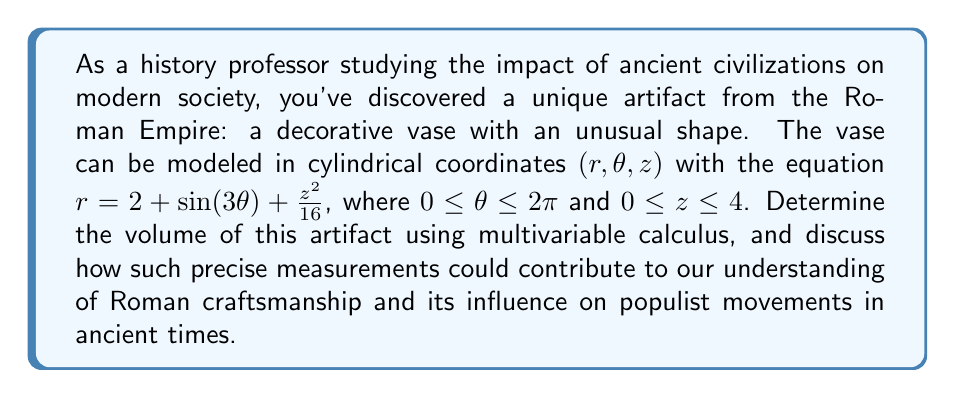What is the answer to this math problem? To find the volume of this complex historical artifact, we need to set up and evaluate a triple integral in cylindrical coordinates. The steps are as follows:

1) The volume integral in cylindrical coordinates is given by:

   $$V = \iiint_V r \, dr \, d\theta \, dz$$

2) We need to determine the limits of integration:
   - $0 \leq \theta \leq 2\pi$
   - $0 \leq z \leq 4$
   - $0 \leq r \leq 2 + \sin(3\theta) + \frac{z^2}{16}$

3) Set up the triple integral:

   $$V = \int_0^4 \int_0^{2\pi} \int_0^{2 + \sin(3\theta) + \frac{z^2}{16}} r \, dr \, d\theta \, dz$$

4) Evaluate the innermost integral with respect to $r$:

   $$V = \int_0^4 \int_0^{2\pi} \left[\frac{r^2}{2}\right]_0^{2 + \sin(3\theta) + \frac{z^2}{16}} \, d\theta \, dz$$
   
   $$V = \int_0^4 \int_0^{2\pi} \frac{1}{2}\left(2 + \sin(3\theta) + \frac{z^2}{16}\right)^2 \, d\theta \, dz$$

5) Expand the squared term:

   $$V = \int_0^4 \int_0^{2\pi} \frac{1}{2}\left(4 + 4\sin(3\theta) + \frac{z^2}{4} + \sin^2(3\theta) + \frac{z^2}{8}\sin(3\theta) + \frac{z^4}{256}\right) \, d\theta \, dz$$

6) Integrate with respect to $\theta$:

   $$V = \int_0^4 \left[\frac{1}{2}\left(4\theta + \frac{4}{3}\cos(3\theta) + \frac{z^2}{4}\theta + \frac{1}{2}\theta - \frac{1}{12}\cos(6\theta) + \frac{z^2}{24}\cos(3\theta) + \frac{z^4}{256}\theta\right)\right]_0^{2\pi} \, dz$$

7) Evaluate the limits for $\theta$:

   $$V = \int_0^4 \left(4\pi + \frac{\pi z^2}{2} + \pi + \frac{\pi z^4}{256}\right) \, dz$$

8) Integrate with respect to $z$:

   $$V = \left[4\pi z + \frac{\pi z^3}{6} + \pi z + \frac{\pi z^5}{1280}\right]_0^4$$

9) Evaluate the limits for $z$:

   $$V = 16\pi + \frac{64\pi}{6} + 4\pi + \frac{1024\pi}{1280}$$

10) Simplify:

    $$V = 16\pi + \frac{32\pi}{3} + 4\pi + \frac{4\pi}{5} = \frac{80\pi}{3} + \frac{4\pi}{5} = \frac{400\pi + 12\pi}{15} = \frac{412\pi}{15}$$

This precise measurement allows us to appreciate the complexity of Roman craftsmanship and provides insight into the technological capabilities of the time. Such advanced mathematical analysis of historical artifacts can help dispel populist myths about the "simplicity" of ancient civilizations and demonstrate the sophistication of their engineering and artistic achievements.
Answer: The volume of the Roman vase is $\frac{412\pi}{15}$ cubic units. 